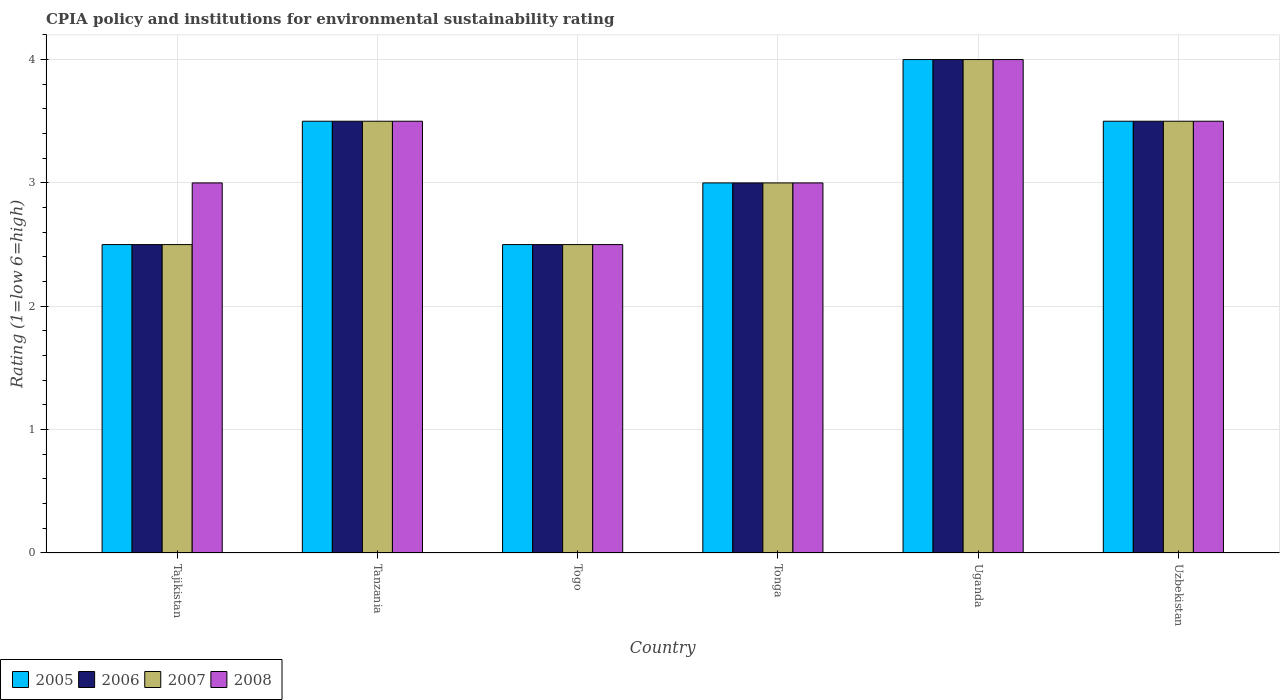Are the number of bars on each tick of the X-axis equal?
Offer a terse response. Yes. How many bars are there on the 6th tick from the left?
Make the answer very short. 4. What is the label of the 3rd group of bars from the left?
Your answer should be compact. Togo. In how many cases, is the number of bars for a given country not equal to the number of legend labels?
Your answer should be very brief. 0. What is the CPIA rating in 2007 in Togo?
Provide a succinct answer. 2.5. Across all countries, what is the minimum CPIA rating in 2005?
Your response must be concise. 2.5. In which country was the CPIA rating in 2006 maximum?
Give a very brief answer. Uganda. In which country was the CPIA rating in 2006 minimum?
Keep it short and to the point. Tajikistan. What is the total CPIA rating in 2007 in the graph?
Make the answer very short. 19. What is the difference between the CPIA rating in 2007 in Tajikistan and that in Uganda?
Offer a terse response. -1.5. What is the difference between the CPIA rating of/in 2008 and CPIA rating of/in 2006 in Togo?
Make the answer very short. 0. What is the difference between the highest and the second highest CPIA rating in 2008?
Provide a short and direct response. -0.5. What is the difference between the highest and the lowest CPIA rating in 2007?
Keep it short and to the point. 1.5. Is the sum of the CPIA rating in 2007 in Tanzania and Uganda greater than the maximum CPIA rating in 2006 across all countries?
Provide a succinct answer. Yes. What does the 1st bar from the right in Togo represents?
Your answer should be very brief. 2008. How many bars are there?
Offer a very short reply. 24. What is the difference between two consecutive major ticks on the Y-axis?
Keep it short and to the point. 1. How are the legend labels stacked?
Ensure brevity in your answer.  Horizontal. What is the title of the graph?
Ensure brevity in your answer.  CPIA policy and institutions for environmental sustainability rating. What is the label or title of the X-axis?
Keep it short and to the point. Country. What is the label or title of the Y-axis?
Provide a short and direct response. Rating (1=low 6=high). What is the Rating (1=low 6=high) of 2006 in Tajikistan?
Provide a succinct answer. 2.5. What is the Rating (1=low 6=high) of 2007 in Tajikistan?
Your answer should be compact. 2.5. What is the Rating (1=low 6=high) in 2008 in Tajikistan?
Give a very brief answer. 3. What is the Rating (1=low 6=high) of 2006 in Tanzania?
Your response must be concise. 3.5. What is the Rating (1=low 6=high) in 2007 in Tanzania?
Provide a short and direct response. 3.5. What is the Rating (1=low 6=high) of 2006 in Togo?
Provide a short and direct response. 2.5. What is the Rating (1=low 6=high) in 2007 in Tonga?
Your answer should be very brief. 3. What is the Rating (1=low 6=high) in 2006 in Uganda?
Your answer should be very brief. 4. What is the Rating (1=low 6=high) of 2007 in Uganda?
Give a very brief answer. 4. What is the Rating (1=low 6=high) in 2006 in Uzbekistan?
Keep it short and to the point. 3.5. What is the Rating (1=low 6=high) of 2007 in Uzbekistan?
Your answer should be very brief. 3.5. What is the Rating (1=low 6=high) in 2008 in Uzbekistan?
Offer a very short reply. 3.5. Across all countries, what is the maximum Rating (1=low 6=high) of 2005?
Offer a terse response. 4. Across all countries, what is the maximum Rating (1=low 6=high) in 2006?
Keep it short and to the point. 4. Across all countries, what is the maximum Rating (1=low 6=high) in 2008?
Ensure brevity in your answer.  4. Across all countries, what is the minimum Rating (1=low 6=high) in 2008?
Provide a succinct answer. 2.5. What is the total Rating (1=low 6=high) in 2005 in the graph?
Ensure brevity in your answer.  19. What is the total Rating (1=low 6=high) in 2006 in the graph?
Offer a terse response. 19. What is the total Rating (1=low 6=high) of 2007 in the graph?
Keep it short and to the point. 19. What is the difference between the Rating (1=low 6=high) of 2005 in Tajikistan and that in Tanzania?
Offer a terse response. -1. What is the difference between the Rating (1=low 6=high) of 2006 in Tajikistan and that in Tanzania?
Ensure brevity in your answer.  -1. What is the difference between the Rating (1=low 6=high) in 2008 in Tajikistan and that in Togo?
Provide a short and direct response. 0.5. What is the difference between the Rating (1=low 6=high) in 2006 in Tajikistan and that in Tonga?
Offer a terse response. -0.5. What is the difference between the Rating (1=low 6=high) of 2007 in Tajikistan and that in Tonga?
Your answer should be compact. -0.5. What is the difference between the Rating (1=low 6=high) of 2008 in Tajikistan and that in Tonga?
Your response must be concise. 0. What is the difference between the Rating (1=low 6=high) in 2007 in Tajikistan and that in Uganda?
Ensure brevity in your answer.  -1.5. What is the difference between the Rating (1=low 6=high) of 2005 in Tajikistan and that in Uzbekistan?
Make the answer very short. -1. What is the difference between the Rating (1=low 6=high) of 2007 in Tajikistan and that in Uzbekistan?
Your answer should be very brief. -1. What is the difference between the Rating (1=low 6=high) in 2008 in Tajikistan and that in Uzbekistan?
Offer a terse response. -0.5. What is the difference between the Rating (1=low 6=high) of 2005 in Tanzania and that in Togo?
Make the answer very short. 1. What is the difference between the Rating (1=low 6=high) in 2006 in Tanzania and that in Tonga?
Provide a succinct answer. 0.5. What is the difference between the Rating (1=low 6=high) in 2008 in Tanzania and that in Tonga?
Your answer should be compact. 0.5. What is the difference between the Rating (1=low 6=high) of 2006 in Tanzania and that in Uganda?
Give a very brief answer. -0.5. What is the difference between the Rating (1=low 6=high) of 2007 in Tanzania and that in Uganda?
Provide a succinct answer. -0.5. What is the difference between the Rating (1=low 6=high) in 2008 in Tanzania and that in Uganda?
Your answer should be very brief. -0.5. What is the difference between the Rating (1=low 6=high) of 2005 in Tanzania and that in Uzbekistan?
Provide a short and direct response. 0. What is the difference between the Rating (1=low 6=high) of 2006 in Tanzania and that in Uzbekistan?
Offer a very short reply. 0. What is the difference between the Rating (1=low 6=high) in 2007 in Tanzania and that in Uzbekistan?
Offer a terse response. 0. What is the difference between the Rating (1=low 6=high) in 2005 in Togo and that in Tonga?
Provide a succinct answer. -0.5. What is the difference between the Rating (1=low 6=high) in 2006 in Togo and that in Tonga?
Offer a terse response. -0.5. What is the difference between the Rating (1=low 6=high) in 2007 in Togo and that in Tonga?
Offer a very short reply. -0.5. What is the difference between the Rating (1=low 6=high) of 2005 in Togo and that in Uganda?
Your response must be concise. -1.5. What is the difference between the Rating (1=low 6=high) of 2007 in Togo and that in Uganda?
Your answer should be very brief. -1.5. What is the difference between the Rating (1=low 6=high) of 2007 in Togo and that in Uzbekistan?
Keep it short and to the point. -1. What is the difference between the Rating (1=low 6=high) in 2005 in Tonga and that in Uganda?
Offer a very short reply. -1. What is the difference between the Rating (1=low 6=high) in 2006 in Tonga and that in Uganda?
Your response must be concise. -1. What is the difference between the Rating (1=low 6=high) of 2007 in Tonga and that in Uganda?
Offer a terse response. -1. What is the difference between the Rating (1=low 6=high) in 2006 in Tonga and that in Uzbekistan?
Your response must be concise. -0.5. What is the difference between the Rating (1=low 6=high) of 2008 in Tonga and that in Uzbekistan?
Your response must be concise. -0.5. What is the difference between the Rating (1=low 6=high) in 2005 in Tajikistan and the Rating (1=low 6=high) in 2007 in Tanzania?
Your answer should be very brief. -1. What is the difference between the Rating (1=low 6=high) of 2005 in Tajikistan and the Rating (1=low 6=high) of 2006 in Togo?
Provide a short and direct response. 0. What is the difference between the Rating (1=low 6=high) of 2005 in Tajikistan and the Rating (1=low 6=high) of 2007 in Togo?
Offer a very short reply. 0. What is the difference between the Rating (1=low 6=high) in 2005 in Tajikistan and the Rating (1=low 6=high) in 2008 in Togo?
Provide a short and direct response. 0. What is the difference between the Rating (1=low 6=high) in 2007 in Tajikistan and the Rating (1=low 6=high) in 2008 in Togo?
Offer a terse response. 0. What is the difference between the Rating (1=low 6=high) in 2005 in Tajikistan and the Rating (1=low 6=high) in 2008 in Tonga?
Provide a succinct answer. -0.5. What is the difference between the Rating (1=low 6=high) of 2006 in Tajikistan and the Rating (1=low 6=high) of 2007 in Tonga?
Make the answer very short. -0.5. What is the difference between the Rating (1=low 6=high) in 2007 in Tajikistan and the Rating (1=low 6=high) in 2008 in Tonga?
Give a very brief answer. -0.5. What is the difference between the Rating (1=low 6=high) in 2005 in Tajikistan and the Rating (1=low 6=high) in 2006 in Uganda?
Make the answer very short. -1.5. What is the difference between the Rating (1=low 6=high) in 2005 in Tajikistan and the Rating (1=low 6=high) in 2007 in Uganda?
Make the answer very short. -1.5. What is the difference between the Rating (1=low 6=high) in 2007 in Tajikistan and the Rating (1=low 6=high) in 2008 in Uganda?
Your response must be concise. -1.5. What is the difference between the Rating (1=low 6=high) of 2005 in Tajikistan and the Rating (1=low 6=high) of 2006 in Uzbekistan?
Your answer should be compact. -1. What is the difference between the Rating (1=low 6=high) in 2005 in Tajikistan and the Rating (1=low 6=high) in 2008 in Uzbekistan?
Your answer should be very brief. -1. What is the difference between the Rating (1=low 6=high) of 2005 in Tanzania and the Rating (1=low 6=high) of 2006 in Togo?
Provide a short and direct response. 1. What is the difference between the Rating (1=low 6=high) of 2005 in Tanzania and the Rating (1=low 6=high) of 2007 in Togo?
Your response must be concise. 1. What is the difference between the Rating (1=low 6=high) in 2006 in Tanzania and the Rating (1=low 6=high) in 2007 in Togo?
Offer a very short reply. 1. What is the difference between the Rating (1=low 6=high) in 2007 in Tanzania and the Rating (1=low 6=high) in 2008 in Togo?
Provide a short and direct response. 1. What is the difference between the Rating (1=low 6=high) of 2005 in Tanzania and the Rating (1=low 6=high) of 2006 in Tonga?
Provide a succinct answer. 0.5. What is the difference between the Rating (1=low 6=high) of 2005 in Tanzania and the Rating (1=low 6=high) of 2007 in Tonga?
Your answer should be compact. 0.5. What is the difference between the Rating (1=low 6=high) in 2006 in Tanzania and the Rating (1=low 6=high) in 2007 in Tonga?
Ensure brevity in your answer.  0.5. What is the difference between the Rating (1=low 6=high) in 2007 in Tanzania and the Rating (1=low 6=high) in 2008 in Tonga?
Make the answer very short. 0.5. What is the difference between the Rating (1=low 6=high) in 2005 in Tanzania and the Rating (1=low 6=high) in 2008 in Uganda?
Provide a short and direct response. -0.5. What is the difference between the Rating (1=low 6=high) of 2006 in Tanzania and the Rating (1=low 6=high) of 2007 in Uganda?
Make the answer very short. -0.5. What is the difference between the Rating (1=low 6=high) of 2005 in Tanzania and the Rating (1=low 6=high) of 2007 in Uzbekistan?
Your answer should be compact. 0. What is the difference between the Rating (1=low 6=high) of 2005 in Tanzania and the Rating (1=low 6=high) of 2008 in Uzbekistan?
Your answer should be very brief. 0. What is the difference between the Rating (1=low 6=high) in 2005 in Togo and the Rating (1=low 6=high) in 2008 in Tonga?
Your response must be concise. -0.5. What is the difference between the Rating (1=low 6=high) of 2006 in Togo and the Rating (1=low 6=high) of 2007 in Tonga?
Make the answer very short. -0.5. What is the difference between the Rating (1=low 6=high) of 2005 in Togo and the Rating (1=low 6=high) of 2008 in Uganda?
Offer a very short reply. -1.5. What is the difference between the Rating (1=low 6=high) of 2005 in Togo and the Rating (1=low 6=high) of 2007 in Uzbekistan?
Your answer should be very brief. -1. What is the difference between the Rating (1=low 6=high) of 2006 in Togo and the Rating (1=low 6=high) of 2007 in Uzbekistan?
Give a very brief answer. -1. What is the difference between the Rating (1=low 6=high) of 2005 in Tonga and the Rating (1=low 6=high) of 2006 in Uganda?
Make the answer very short. -1. What is the difference between the Rating (1=low 6=high) in 2005 in Tonga and the Rating (1=low 6=high) in 2008 in Uganda?
Provide a short and direct response. -1. What is the difference between the Rating (1=low 6=high) of 2006 in Tonga and the Rating (1=low 6=high) of 2007 in Uganda?
Make the answer very short. -1. What is the difference between the Rating (1=low 6=high) in 2006 in Tonga and the Rating (1=low 6=high) in 2008 in Uganda?
Provide a short and direct response. -1. What is the difference between the Rating (1=low 6=high) in 2005 in Tonga and the Rating (1=low 6=high) in 2007 in Uzbekistan?
Provide a succinct answer. -0.5. What is the difference between the Rating (1=low 6=high) in 2005 in Tonga and the Rating (1=low 6=high) in 2008 in Uzbekistan?
Ensure brevity in your answer.  -0.5. What is the difference between the Rating (1=low 6=high) of 2007 in Tonga and the Rating (1=low 6=high) of 2008 in Uzbekistan?
Provide a short and direct response. -0.5. What is the difference between the Rating (1=low 6=high) of 2005 in Uganda and the Rating (1=low 6=high) of 2008 in Uzbekistan?
Make the answer very short. 0.5. What is the difference between the Rating (1=low 6=high) in 2006 in Uganda and the Rating (1=low 6=high) in 2007 in Uzbekistan?
Your response must be concise. 0.5. What is the difference between the Rating (1=low 6=high) of 2007 in Uganda and the Rating (1=low 6=high) of 2008 in Uzbekistan?
Your answer should be compact. 0.5. What is the average Rating (1=low 6=high) in 2005 per country?
Make the answer very short. 3.17. What is the average Rating (1=low 6=high) of 2006 per country?
Your response must be concise. 3.17. What is the average Rating (1=low 6=high) in 2007 per country?
Ensure brevity in your answer.  3.17. What is the average Rating (1=low 6=high) of 2008 per country?
Ensure brevity in your answer.  3.25. What is the difference between the Rating (1=low 6=high) of 2005 and Rating (1=low 6=high) of 2008 in Tajikistan?
Your answer should be compact. -0.5. What is the difference between the Rating (1=low 6=high) in 2006 and Rating (1=low 6=high) in 2007 in Tajikistan?
Offer a very short reply. 0. What is the difference between the Rating (1=low 6=high) in 2007 and Rating (1=low 6=high) in 2008 in Tajikistan?
Provide a succinct answer. -0.5. What is the difference between the Rating (1=low 6=high) in 2005 and Rating (1=low 6=high) in 2007 in Tanzania?
Provide a short and direct response. 0. What is the difference between the Rating (1=low 6=high) in 2006 and Rating (1=low 6=high) in 2007 in Tanzania?
Ensure brevity in your answer.  0. What is the difference between the Rating (1=low 6=high) of 2006 and Rating (1=low 6=high) of 2008 in Tanzania?
Your answer should be very brief. 0. What is the difference between the Rating (1=low 6=high) in 2005 and Rating (1=low 6=high) in 2007 in Togo?
Provide a succinct answer. 0. What is the difference between the Rating (1=low 6=high) in 2006 and Rating (1=low 6=high) in 2008 in Togo?
Your answer should be very brief. 0. What is the difference between the Rating (1=low 6=high) of 2005 and Rating (1=low 6=high) of 2007 in Tonga?
Keep it short and to the point. 0. What is the difference between the Rating (1=low 6=high) in 2006 and Rating (1=low 6=high) in 2007 in Tonga?
Offer a very short reply. 0. What is the difference between the Rating (1=low 6=high) of 2006 and Rating (1=low 6=high) of 2008 in Tonga?
Provide a short and direct response. 0. What is the difference between the Rating (1=low 6=high) in 2007 and Rating (1=low 6=high) in 2008 in Tonga?
Your answer should be compact. 0. What is the difference between the Rating (1=low 6=high) in 2005 and Rating (1=low 6=high) in 2006 in Uganda?
Provide a succinct answer. 0. What is the difference between the Rating (1=low 6=high) in 2005 and Rating (1=low 6=high) in 2008 in Uganda?
Your response must be concise. 0. What is the difference between the Rating (1=low 6=high) in 2006 and Rating (1=low 6=high) in 2007 in Uganda?
Provide a short and direct response. 0. What is the difference between the Rating (1=low 6=high) in 2006 and Rating (1=low 6=high) in 2008 in Uganda?
Your answer should be compact. 0. What is the difference between the Rating (1=low 6=high) of 2007 and Rating (1=low 6=high) of 2008 in Uganda?
Your response must be concise. 0. What is the difference between the Rating (1=low 6=high) of 2005 and Rating (1=low 6=high) of 2008 in Uzbekistan?
Keep it short and to the point. 0. What is the ratio of the Rating (1=low 6=high) of 2008 in Tajikistan to that in Tanzania?
Your response must be concise. 0.86. What is the ratio of the Rating (1=low 6=high) of 2005 in Tajikistan to that in Togo?
Keep it short and to the point. 1. What is the ratio of the Rating (1=low 6=high) in 2006 in Tajikistan to that in Togo?
Your response must be concise. 1. What is the ratio of the Rating (1=low 6=high) of 2007 in Tajikistan to that in Togo?
Make the answer very short. 1. What is the ratio of the Rating (1=low 6=high) of 2005 in Tajikistan to that in Tonga?
Your response must be concise. 0.83. What is the ratio of the Rating (1=low 6=high) in 2006 in Tajikistan to that in Tonga?
Ensure brevity in your answer.  0.83. What is the ratio of the Rating (1=low 6=high) of 2007 in Tajikistan to that in Tonga?
Offer a terse response. 0.83. What is the ratio of the Rating (1=low 6=high) in 2008 in Tajikistan to that in Tonga?
Your answer should be compact. 1. What is the ratio of the Rating (1=low 6=high) in 2005 in Tajikistan to that in Uganda?
Provide a short and direct response. 0.62. What is the ratio of the Rating (1=low 6=high) in 2008 in Tajikistan to that in Uganda?
Keep it short and to the point. 0.75. What is the ratio of the Rating (1=low 6=high) of 2005 in Tajikistan to that in Uzbekistan?
Give a very brief answer. 0.71. What is the ratio of the Rating (1=low 6=high) of 2005 in Tanzania to that in Togo?
Keep it short and to the point. 1.4. What is the ratio of the Rating (1=low 6=high) in 2005 in Tanzania to that in Tonga?
Provide a succinct answer. 1.17. What is the ratio of the Rating (1=low 6=high) in 2006 in Tanzania to that in Tonga?
Ensure brevity in your answer.  1.17. What is the ratio of the Rating (1=low 6=high) in 2005 in Tanzania to that in Uganda?
Make the answer very short. 0.88. What is the ratio of the Rating (1=low 6=high) in 2006 in Tanzania to that in Uganda?
Keep it short and to the point. 0.88. What is the ratio of the Rating (1=low 6=high) of 2005 in Tanzania to that in Uzbekistan?
Your answer should be very brief. 1. What is the ratio of the Rating (1=low 6=high) in 2008 in Tanzania to that in Uzbekistan?
Offer a terse response. 1. What is the ratio of the Rating (1=low 6=high) of 2005 in Togo to that in Tonga?
Provide a succinct answer. 0.83. What is the ratio of the Rating (1=low 6=high) of 2008 in Togo to that in Tonga?
Ensure brevity in your answer.  0.83. What is the ratio of the Rating (1=low 6=high) of 2006 in Togo to that in Uganda?
Your response must be concise. 0.62. What is the ratio of the Rating (1=low 6=high) of 2007 in Togo to that in Uganda?
Make the answer very short. 0.62. What is the ratio of the Rating (1=low 6=high) in 2008 in Togo to that in Uganda?
Your response must be concise. 0.62. What is the ratio of the Rating (1=low 6=high) of 2006 in Togo to that in Uzbekistan?
Give a very brief answer. 0.71. What is the ratio of the Rating (1=low 6=high) of 2007 in Togo to that in Uzbekistan?
Ensure brevity in your answer.  0.71. What is the ratio of the Rating (1=low 6=high) of 2005 in Tonga to that in Uganda?
Offer a terse response. 0.75. What is the ratio of the Rating (1=low 6=high) in 2006 in Tonga to that in Uzbekistan?
Your answer should be very brief. 0.86. What is the ratio of the Rating (1=low 6=high) in 2007 in Tonga to that in Uzbekistan?
Offer a terse response. 0.86. What is the ratio of the Rating (1=low 6=high) of 2008 in Tonga to that in Uzbekistan?
Keep it short and to the point. 0.86. What is the ratio of the Rating (1=low 6=high) of 2005 in Uganda to that in Uzbekistan?
Your response must be concise. 1.14. What is the ratio of the Rating (1=low 6=high) of 2007 in Uganda to that in Uzbekistan?
Ensure brevity in your answer.  1.14. What is the ratio of the Rating (1=low 6=high) in 2008 in Uganda to that in Uzbekistan?
Your answer should be compact. 1.14. What is the difference between the highest and the second highest Rating (1=low 6=high) of 2005?
Keep it short and to the point. 0.5. What is the difference between the highest and the lowest Rating (1=low 6=high) of 2005?
Give a very brief answer. 1.5. What is the difference between the highest and the lowest Rating (1=low 6=high) in 2006?
Your answer should be compact. 1.5. What is the difference between the highest and the lowest Rating (1=low 6=high) of 2007?
Your answer should be very brief. 1.5. 